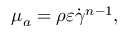Convert formula to latex. <formula><loc_0><loc_0><loc_500><loc_500>\mu _ { a } = \rho \varepsilon \dot { \gamma } ^ { n - 1 } ,</formula> 